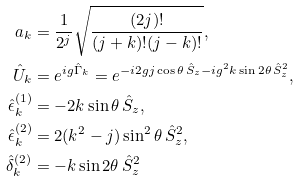Convert formula to latex. <formula><loc_0><loc_0><loc_500><loc_500>a _ { k } & = \frac { 1 } { 2 ^ { j } } \sqrt { \frac { ( 2 j ) ! } { ( j + k ) ! ( j - k ) ! } } , \\ \hat { U } _ { k } & = e ^ { i g \hat { \Gamma } _ { k } } = e ^ { - i 2 g j \cos \theta \, \hat { S } _ { z } - i g ^ { 2 } k \sin 2 \theta \, \hat { S } _ { z } ^ { 2 } } , \\ \hat { \epsilon } _ { k } ^ { ( 1 ) } & = - 2 k \sin \theta \, \hat { S } _ { z } , \\ \hat { \epsilon } _ { k } ^ { ( 2 ) } & = 2 ( k ^ { 2 } - j ) \sin ^ { 2 } \theta \, \hat { S } _ { z } ^ { 2 } , \\ \hat { \delta } _ { k } ^ { ( 2 ) } & = - k \sin 2 \theta \, \hat { S } _ { z } ^ { 2 }</formula> 